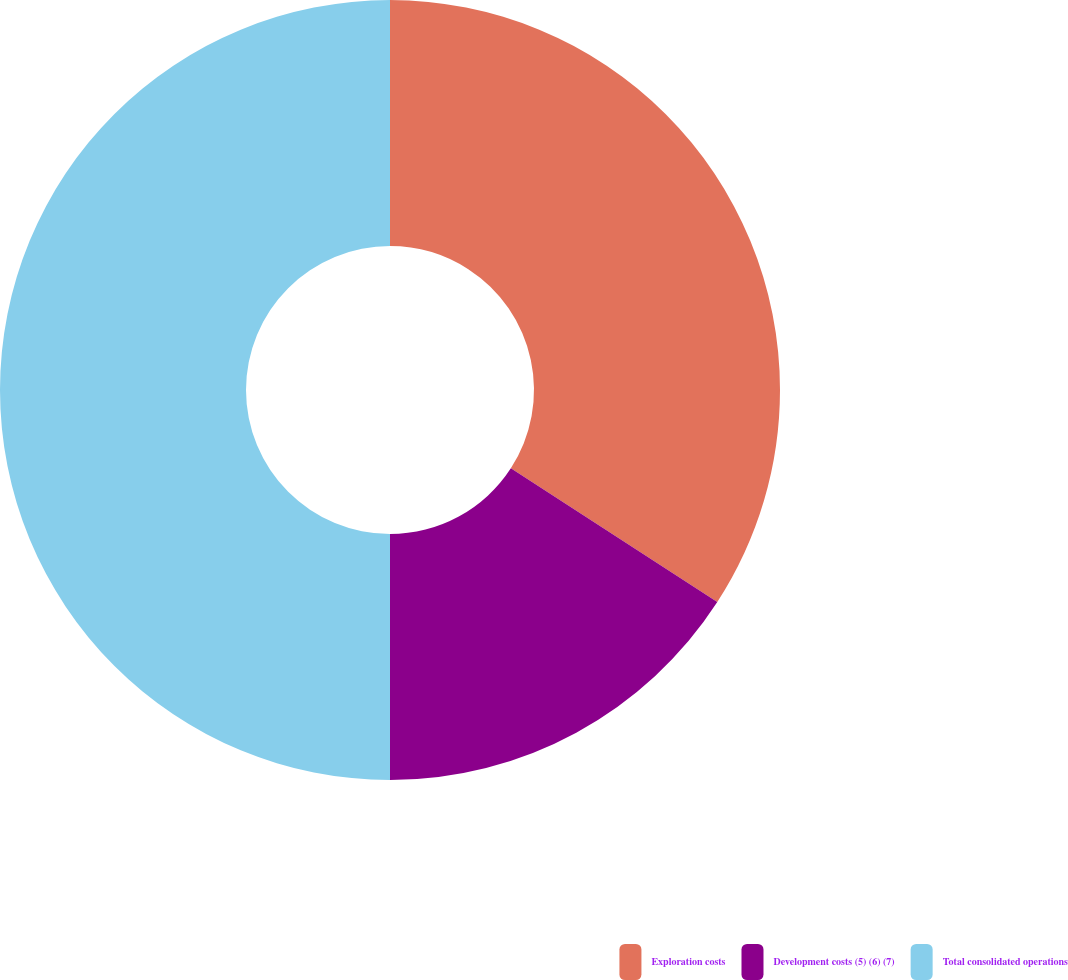Convert chart to OTSL. <chart><loc_0><loc_0><loc_500><loc_500><pie_chart><fcel>Exploration costs<fcel>Development costs (5) (6) (7)<fcel>Total consolidated operations<nl><fcel>34.15%<fcel>15.85%<fcel>50.0%<nl></chart> 